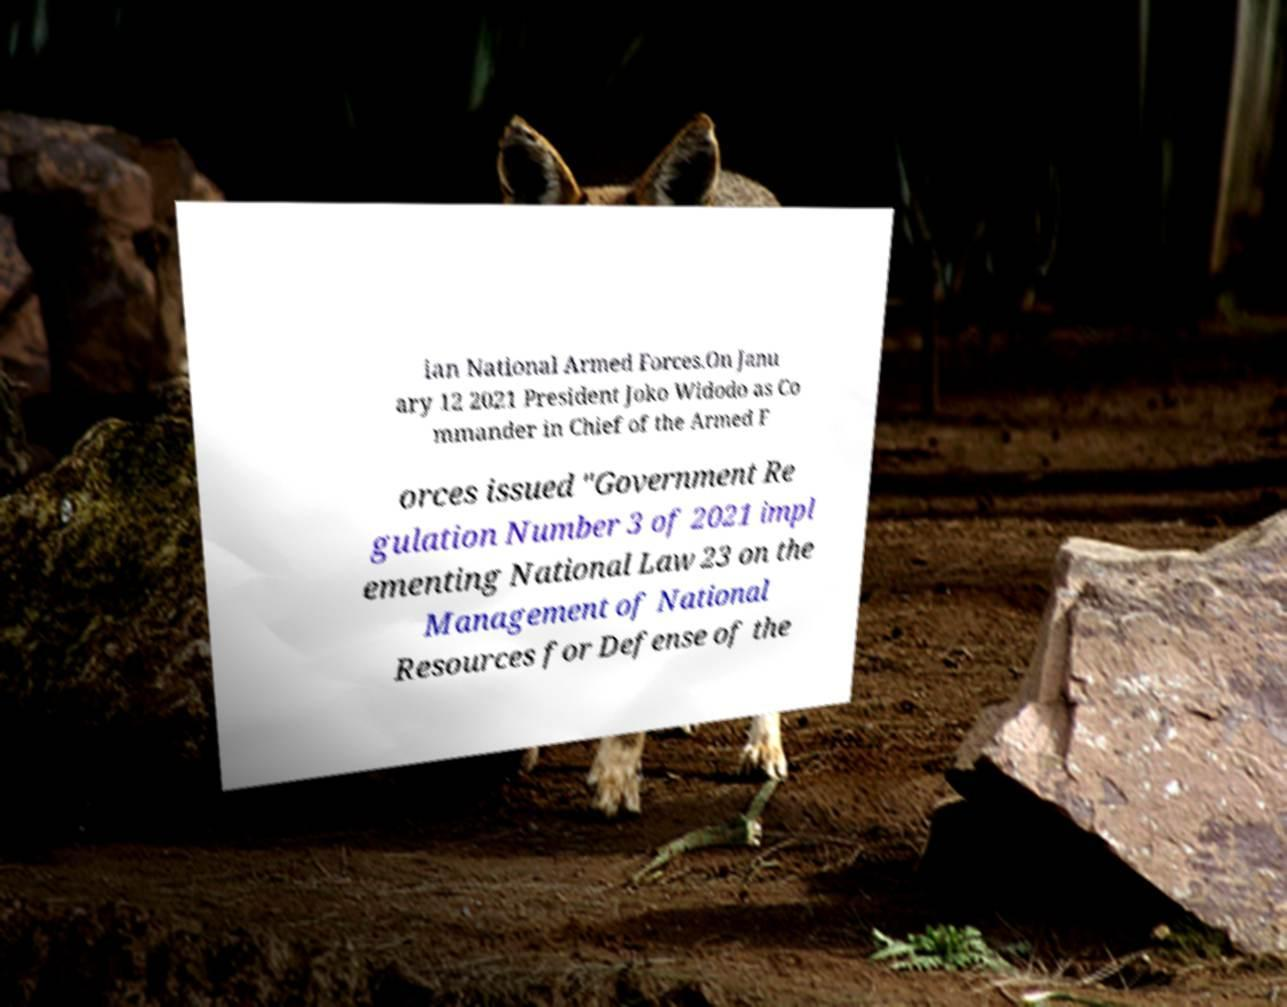Could you assist in decoding the text presented in this image and type it out clearly? ian National Armed Forces.On Janu ary 12 2021 President Joko Widodo as Co mmander in Chief of the Armed F orces issued "Government Re gulation Number 3 of 2021 impl ementing National Law 23 on the Management of National Resources for Defense of the 